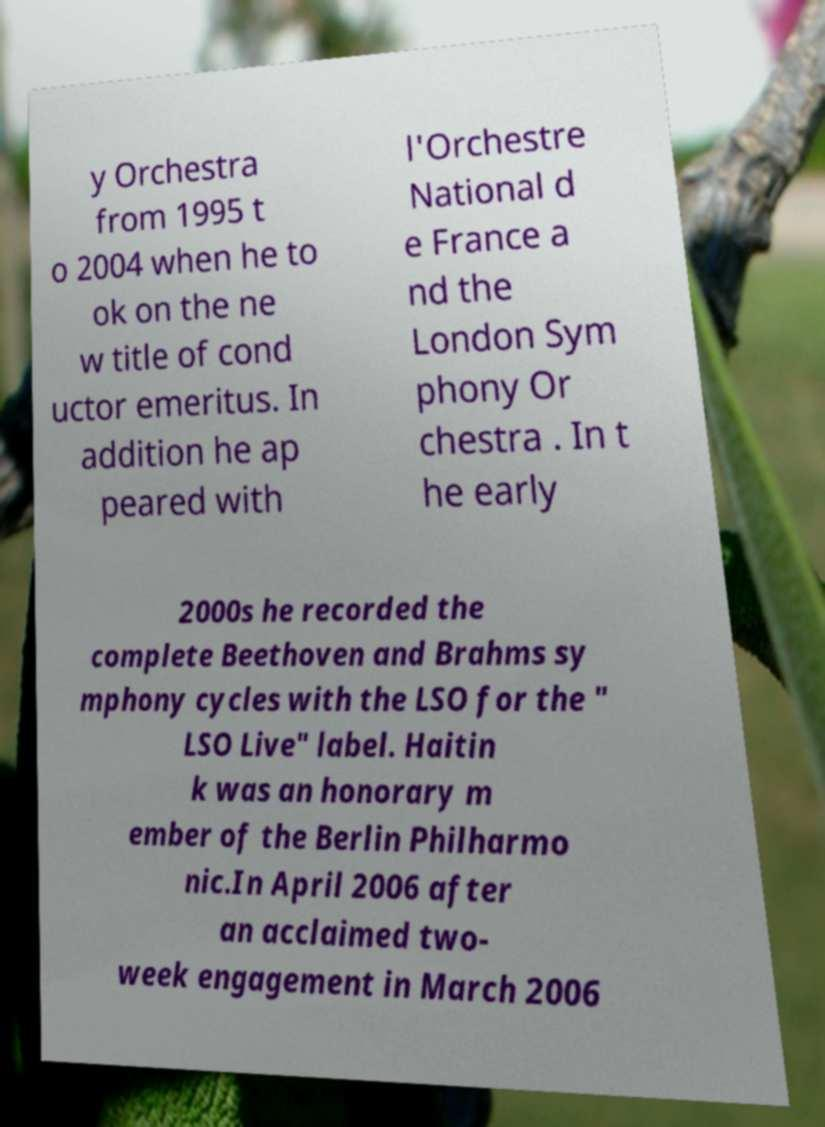Could you extract and type out the text from this image? y Orchestra from 1995 t o 2004 when he to ok on the ne w title of cond uctor emeritus. In addition he ap peared with l'Orchestre National d e France a nd the London Sym phony Or chestra . In t he early 2000s he recorded the complete Beethoven and Brahms sy mphony cycles with the LSO for the " LSO Live" label. Haitin k was an honorary m ember of the Berlin Philharmo nic.In April 2006 after an acclaimed two- week engagement in March 2006 